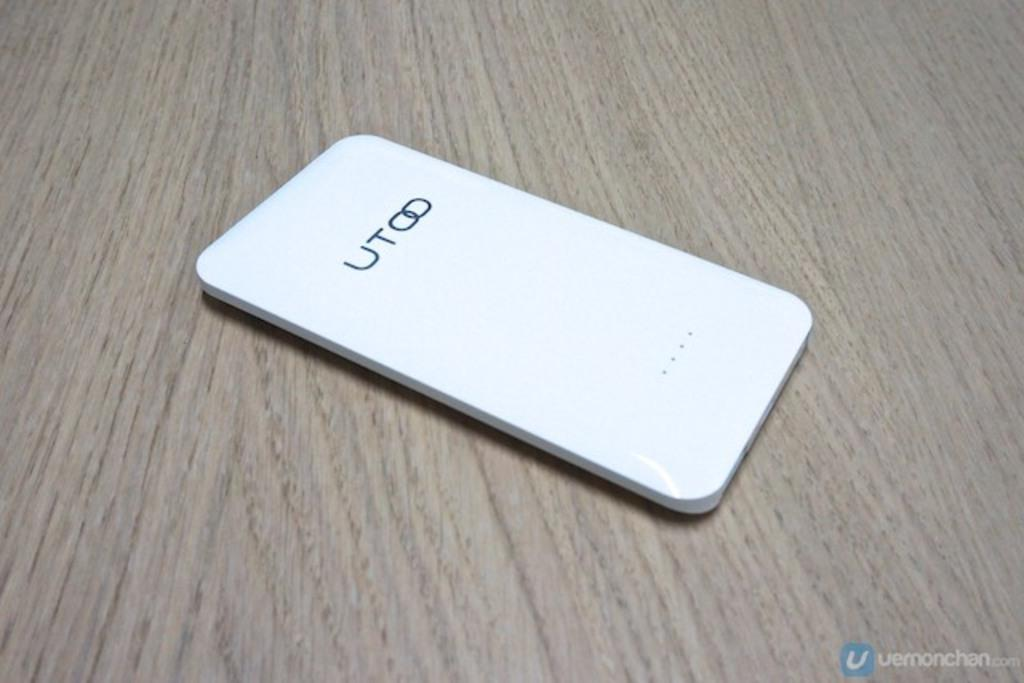<image>
Describe the image concisely. A phone manufactured by UTOO laying on a wood grained table. 